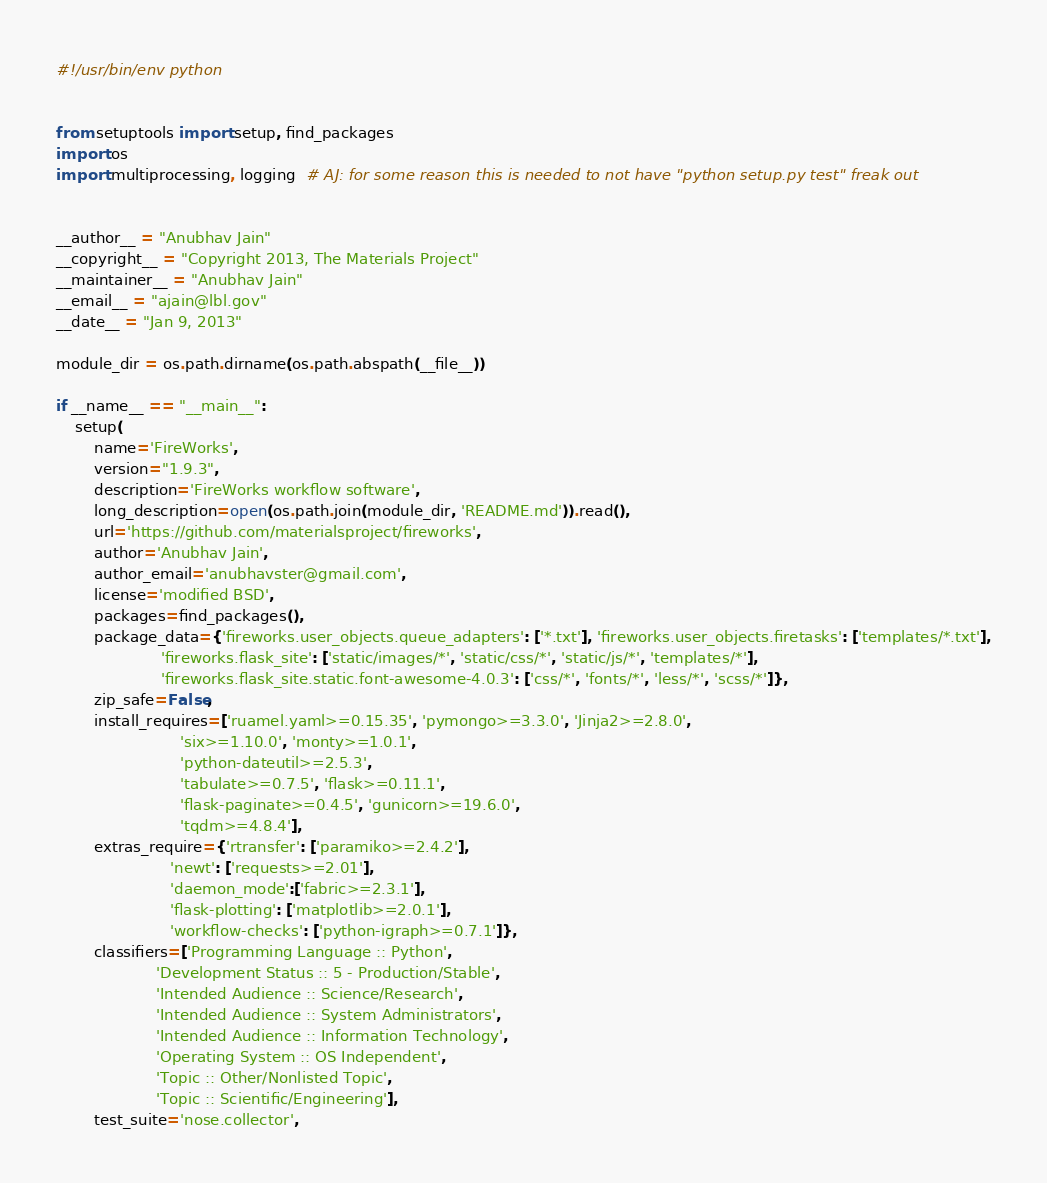<code> <loc_0><loc_0><loc_500><loc_500><_Python_>#!/usr/bin/env python


from setuptools import setup, find_packages
import os
import multiprocessing, logging  # AJ: for some reason this is needed to not have "python setup.py test" freak out


__author__ = "Anubhav Jain"
__copyright__ = "Copyright 2013, The Materials Project"
__maintainer__ = "Anubhav Jain"
__email__ = "ajain@lbl.gov"
__date__ = "Jan 9, 2013"

module_dir = os.path.dirname(os.path.abspath(__file__))

if __name__ == "__main__":
    setup(
        name='FireWorks',
        version="1.9.3",
        description='FireWorks workflow software',
        long_description=open(os.path.join(module_dir, 'README.md')).read(),
        url='https://github.com/materialsproject/fireworks',
        author='Anubhav Jain',
        author_email='anubhavster@gmail.com',
        license='modified BSD',
        packages=find_packages(),
        package_data={'fireworks.user_objects.queue_adapters': ['*.txt'], 'fireworks.user_objects.firetasks': ['templates/*.txt'],
                      'fireworks.flask_site': ['static/images/*', 'static/css/*', 'static/js/*', 'templates/*'],
                      'fireworks.flask_site.static.font-awesome-4.0.3': ['css/*', 'fonts/*', 'less/*', 'scss/*']},
        zip_safe=False,
        install_requires=['ruamel.yaml>=0.15.35', 'pymongo>=3.3.0', 'Jinja2>=2.8.0',
                          'six>=1.10.0', 'monty>=1.0.1',
                          'python-dateutil>=2.5.3',
                          'tabulate>=0.7.5', 'flask>=0.11.1',
                          'flask-paginate>=0.4.5', 'gunicorn>=19.6.0',
                          'tqdm>=4.8.4'],
        extras_require={'rtransfer': ['paramiko>=2.4.2'],
                        'newt': ['requests>=2.01'],
                        'daemon_mode':['fabric>=2.3.1'],
                        'flask-plotting': ['matplotlib>=2.0.1'],
                        'workflow-checks': ['python-igraph>=0.7.1']},
        classifiers=['Programming Language :: Python',
                     'Development Status :: 5 - Production/Stable',
                     'Intended Audience :: Science/Research',
                     'Intended Audience :: System Administrators',
                     'Intended Audience :: Information Technology',
                     'Operating System :: OS Independent',
                     'Topic :: Other/Nonlisted Topic',
                     'Topic :: Scientific/Engineering'],
        test_suite='nose.collector',</code> 